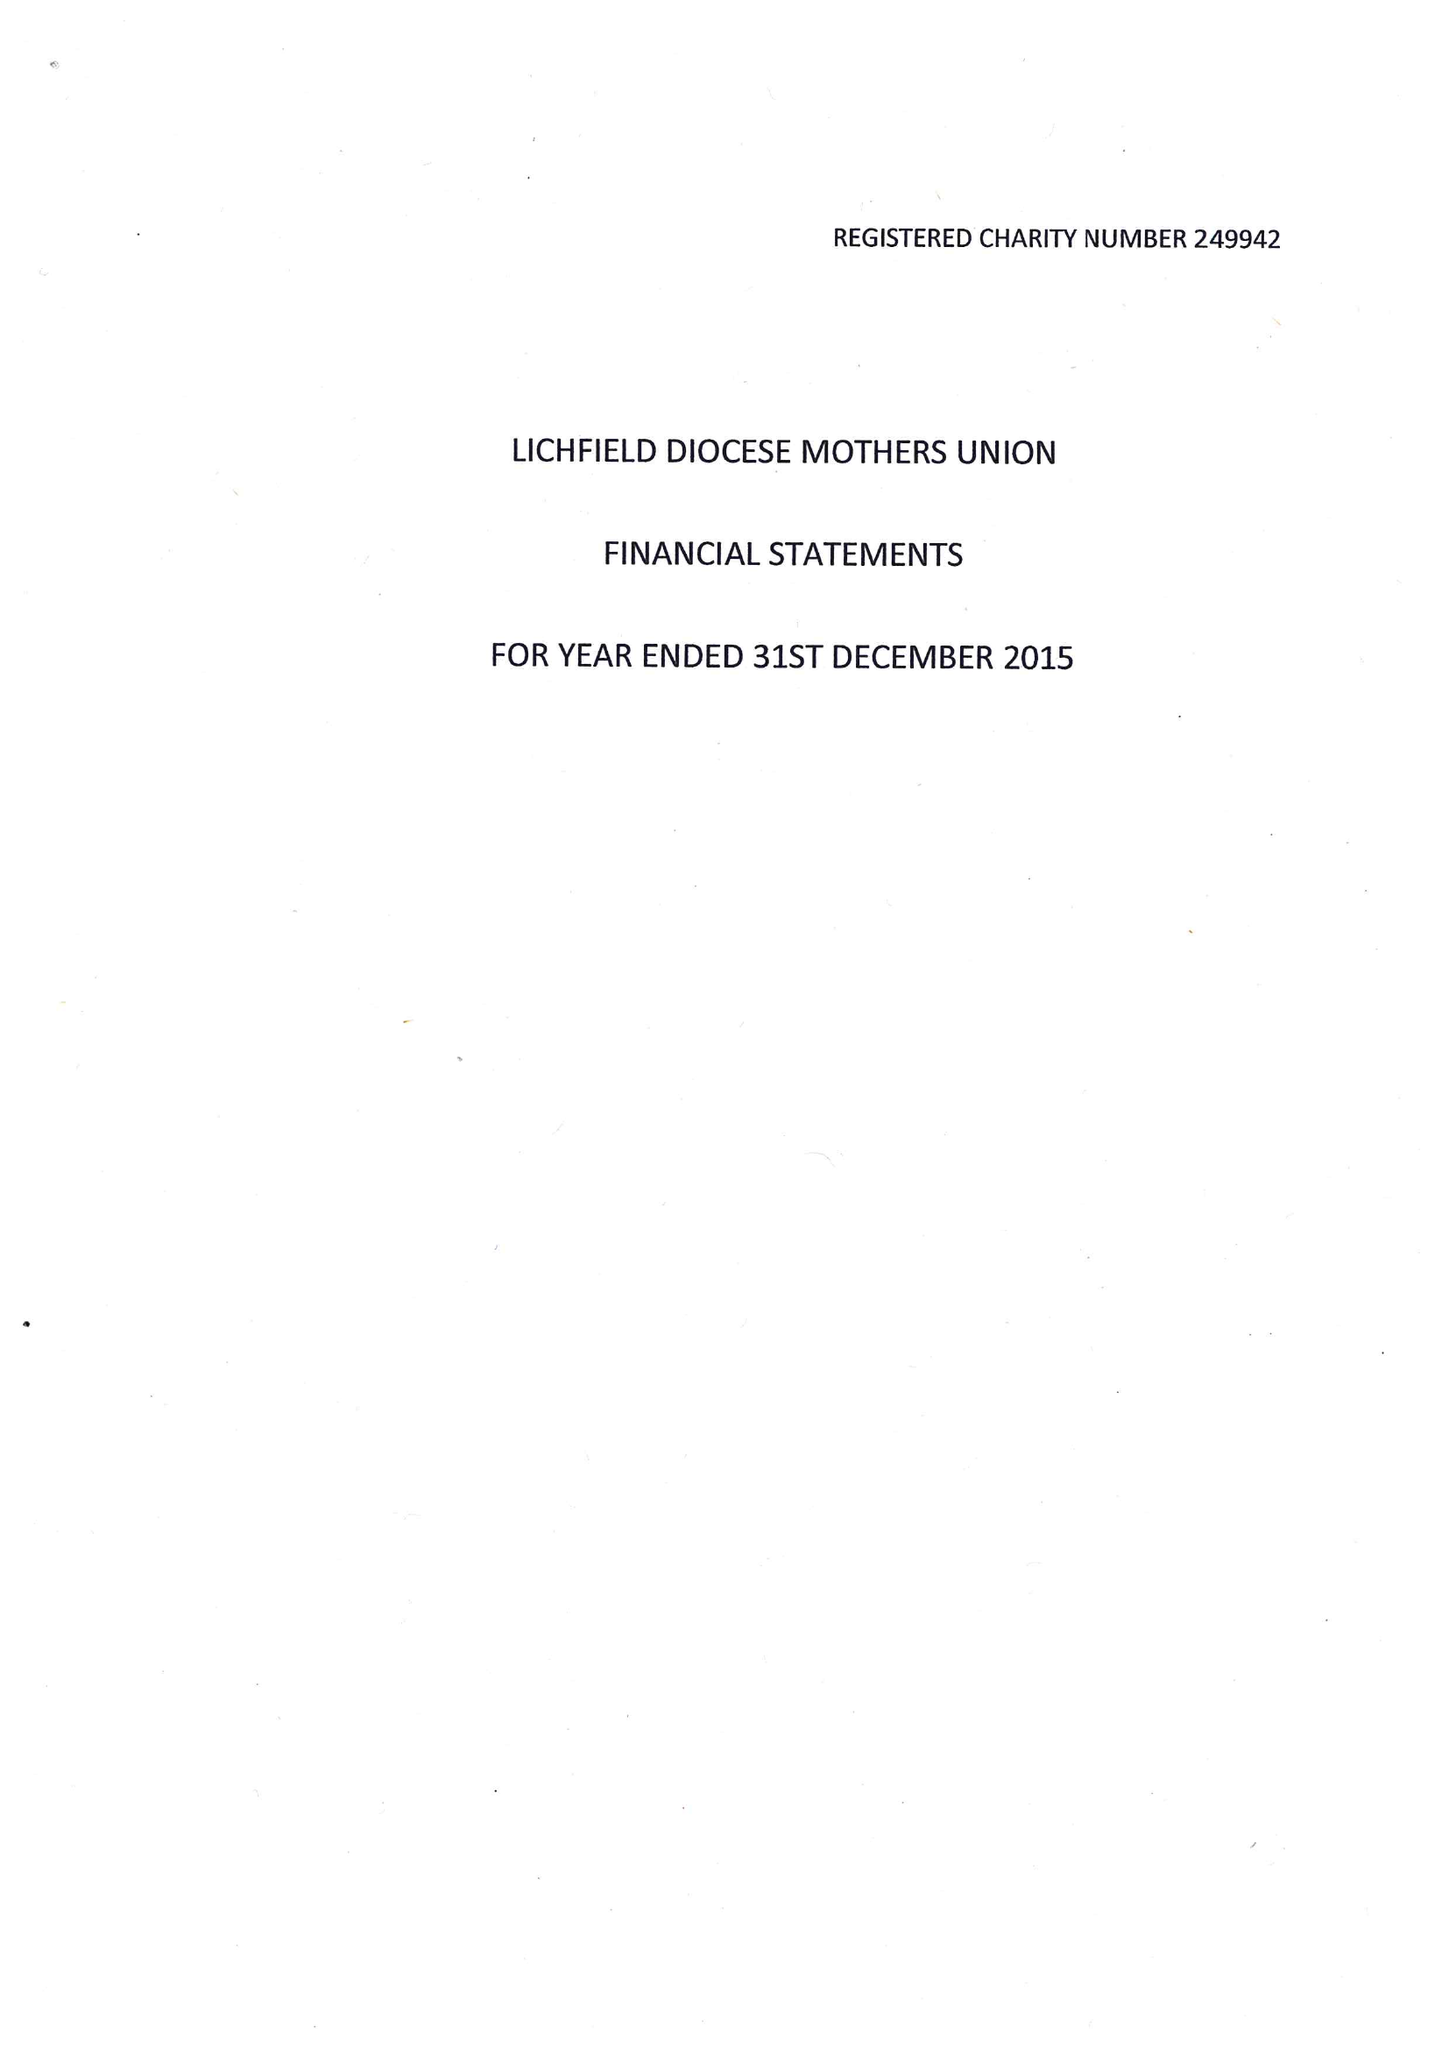What is the value for the report_date?
Answer the question using a single word or phrase. 2015-12-31 